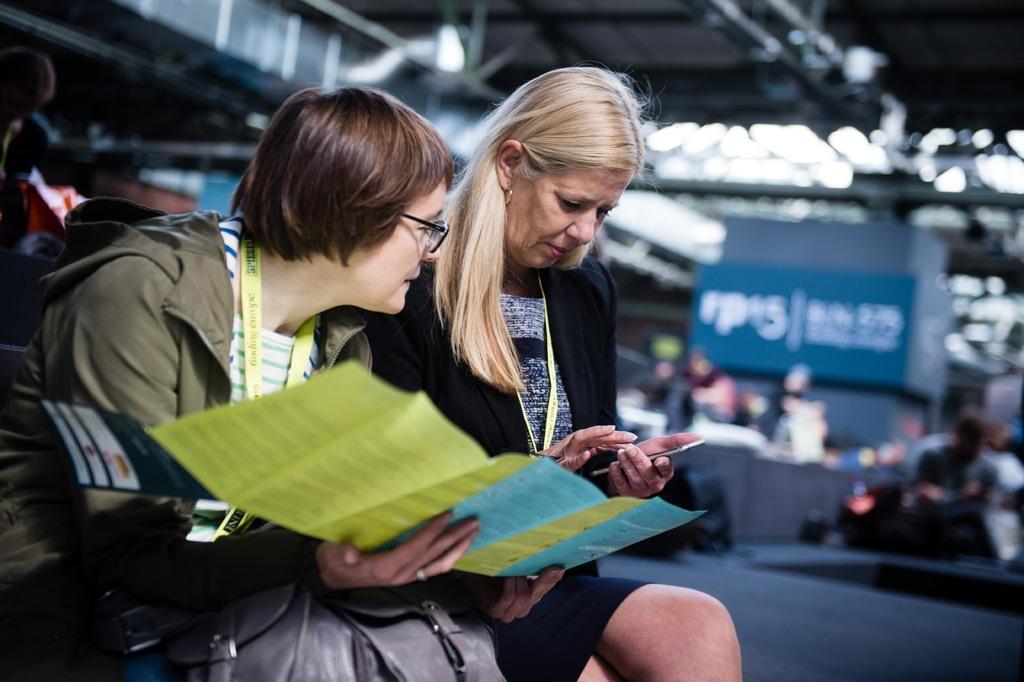Describe this image in one or two sentences. In this picture I can see there are two woman sitting here and there is a smart phone in this person's hand and the other woman is holding a paper and in the backdrop I can see there are some people standing. 